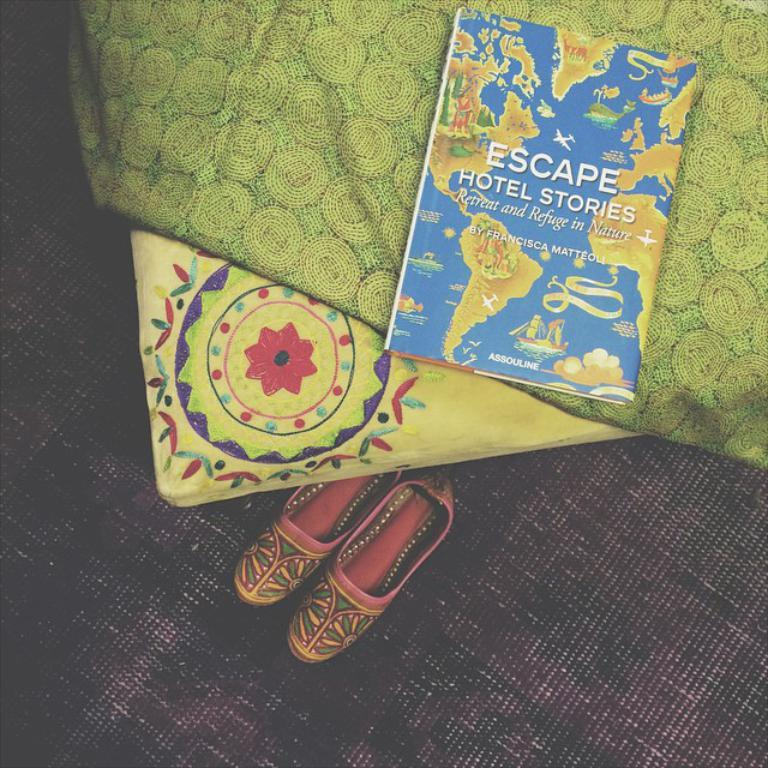<image>
Present a compact description of the photo's key features. A book called Escape Hotel Stories by Francisca Matteoli 